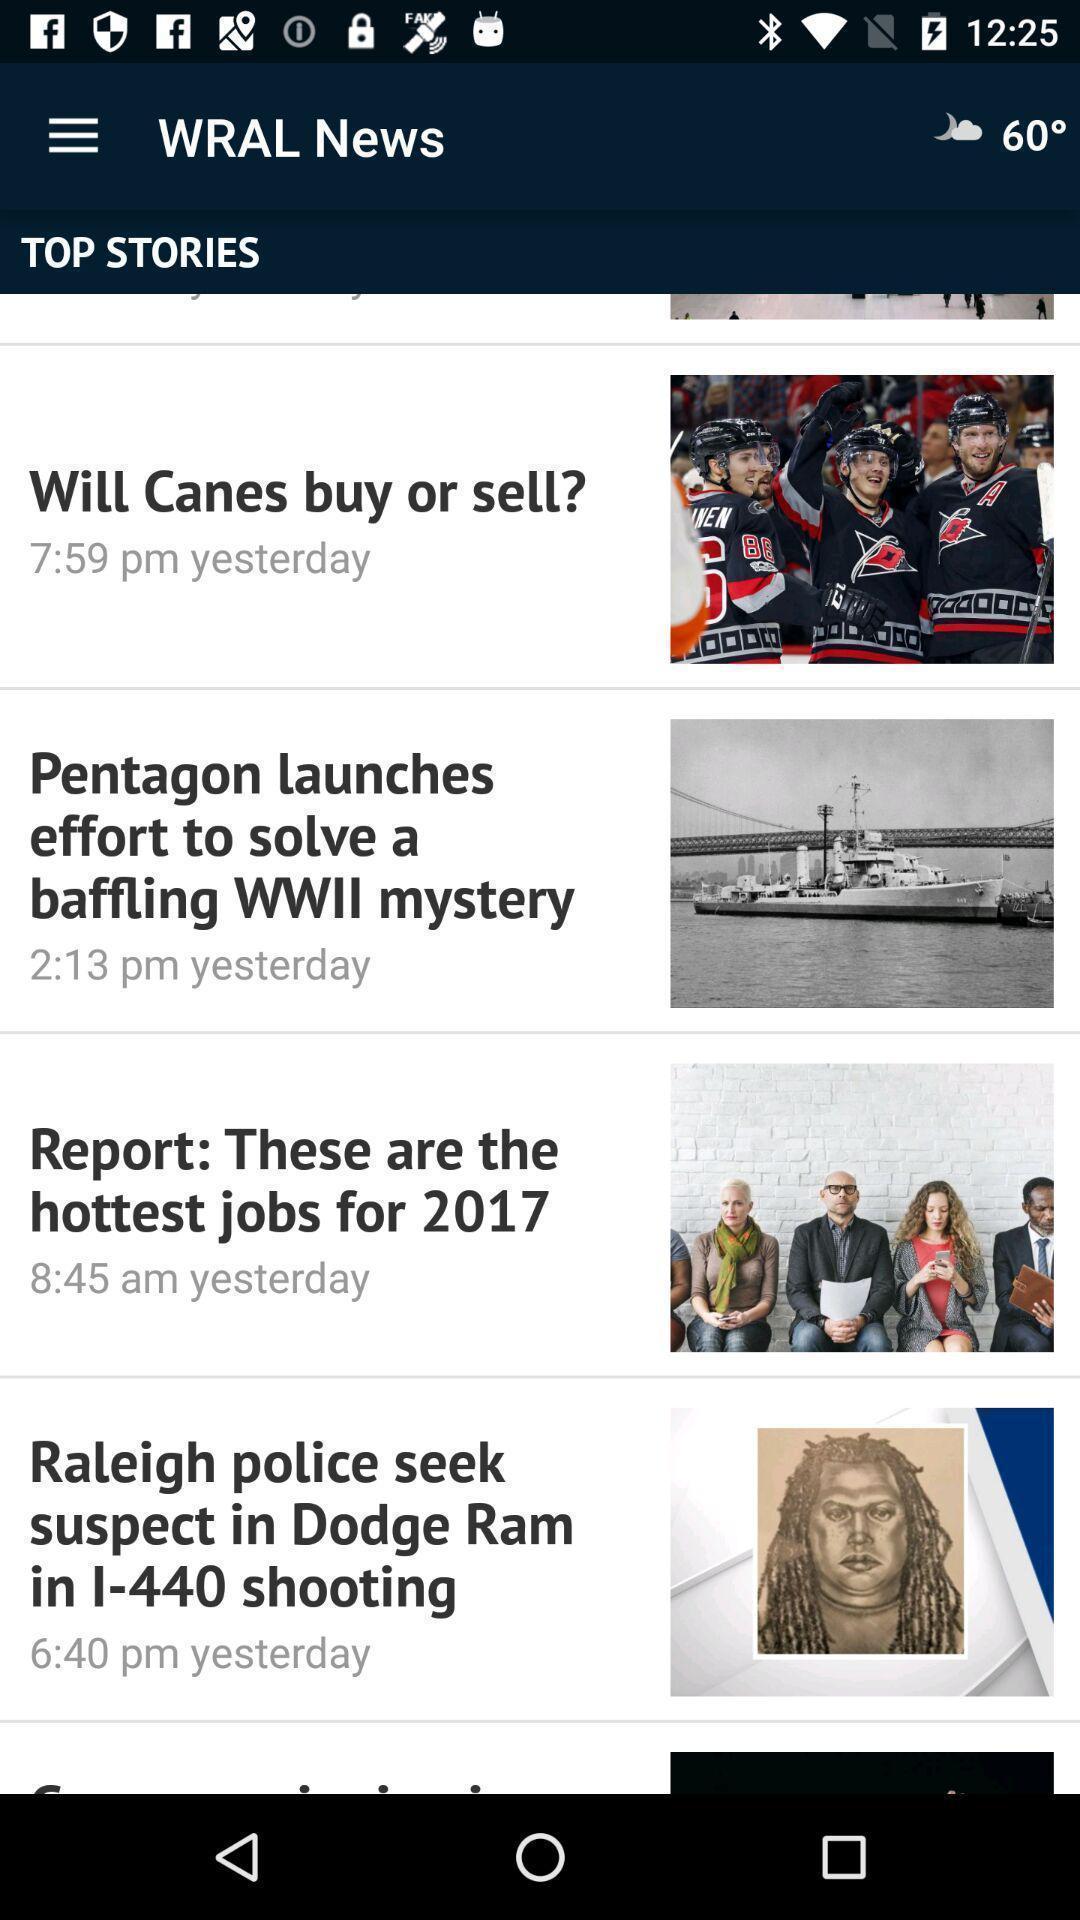Describe this image in words. Page shows the top stories. 